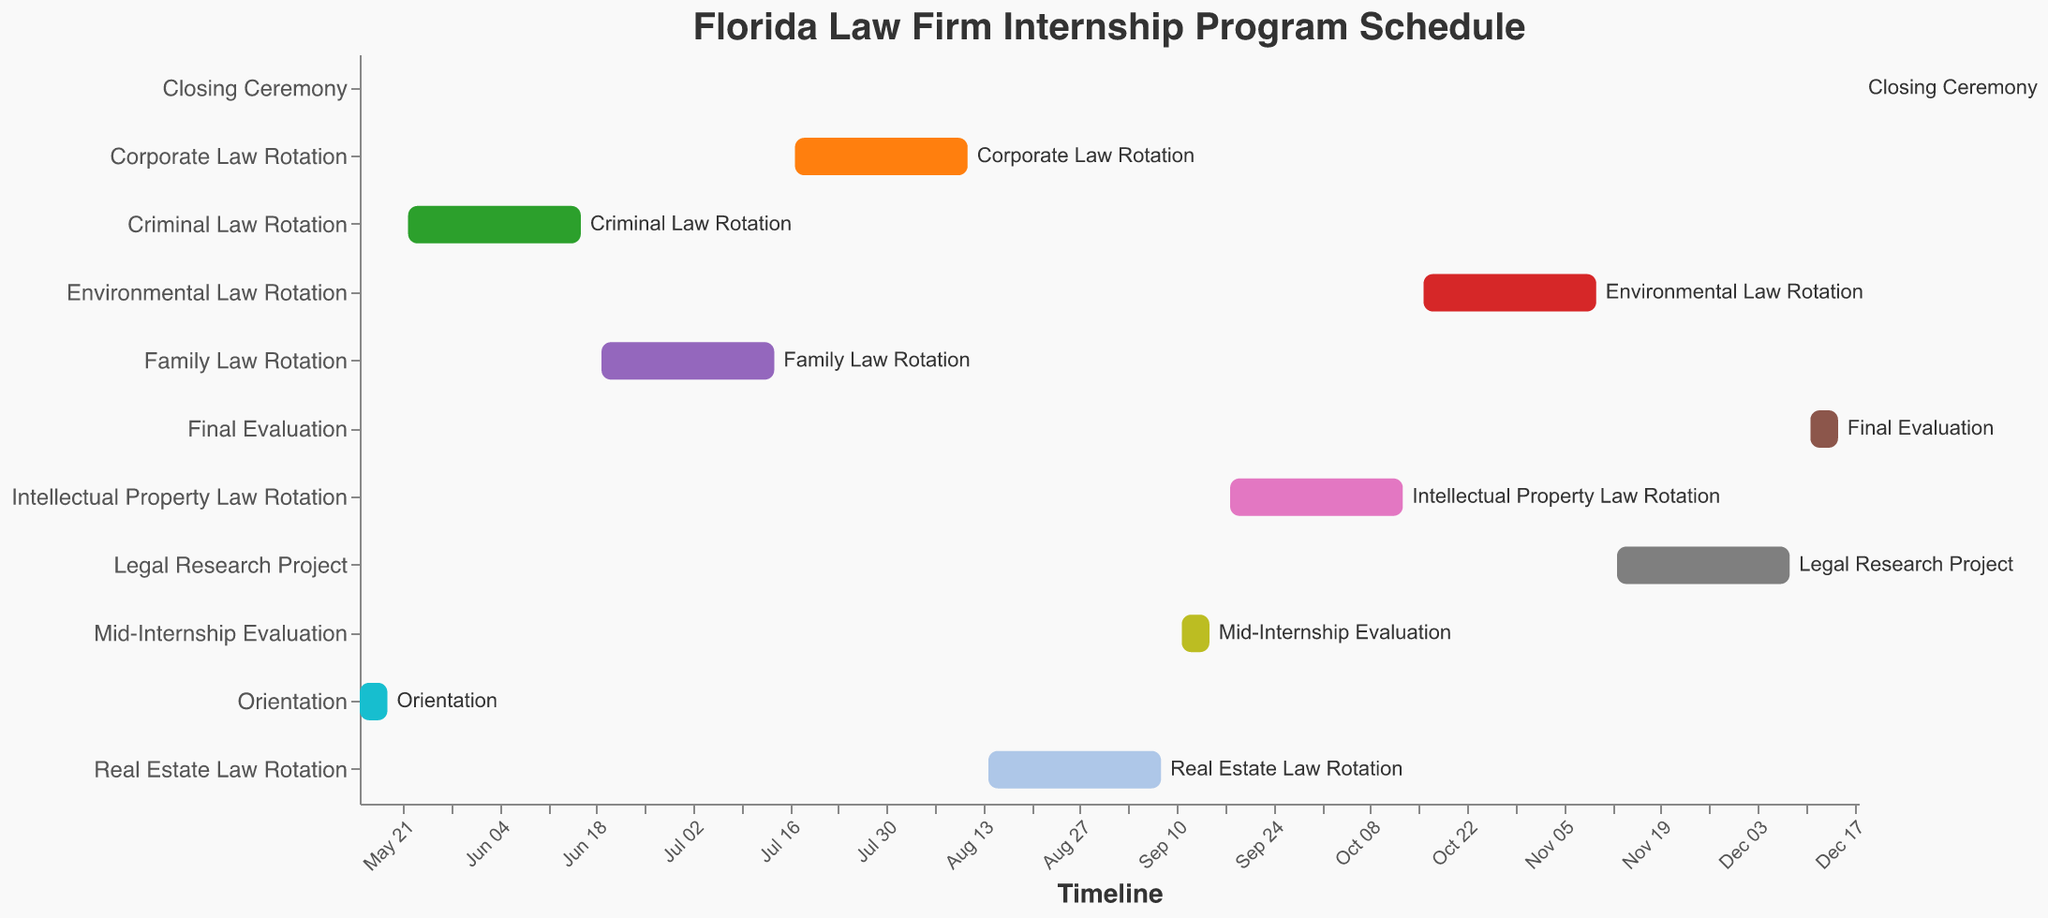How long does the Corporate Law Rotation last? To find the duration, identify the start and end dates for the Corporate Law Rotation. The start date is July 17, 2023, and the end date is August 11, 2023. Count the days from the start date to the end date.
Answer: 26 days When does the longest rotation start and end? Scan all the tasks to identify the longest rotation. The longest rotation is the Criminal Law Rotation, starting on May 22, 2023, and ending on June 16, 2023.
Answer: May 22, 2023 - June 16, 2023 Which rotation directly follows the Mid-Internship Evaluation? Locate the Mid-Internship Evaluation, which is scheduled from September 11 to September 15. The next task on the timeline is the Intellectual Property Law Rotation starting on September 18, 2023.
Answer: Intellectual Property Law Rotation How many total tasks are included in the internship program? Count the number of different tasks listed on the y-axis of the Gantt chart.
Answer: 11 tasks What is the duration of the Legal Research Project, and how does it compare to the Final Evaluation? The Legal Research Project runs from November 13 to December 8, which is 26 days. The Final Evaluation runs from December 11 to December 15, which is 5 days. Comparing the durations, the Legal Research Project is 21 days longer than the Final Evaluation.
Answer: Legal Research Project: 26 days, Final Evaluation: 5 days, Difference: 21 days When is the Closing Ceremony held? Look at the end of the Gantt chart to find the Closing Ceremony, which is on December 18, 2023.
Answer: December 18, 2023 Between which dates does the Family Law Rotation occur? Locate the Family Law Rotation on the y-axis and trace the corresponding range on the x-axis, which shows it runs from June 19, 2023, to July 14, 2023.
Answer: June 19, 2023 - July 14, 2023 How many days are there between the end of the Real Estate Law Rotation and the start of the Mid-Internship Evaluation? The Real Estate Law Rotation ends on September 8, and the Mid-Internship Evaluation starts on September 11. Counting the days between these dates: September 9 and 10 are two days.
Answer: 2 days List all tasks that occur in December. Identify tasks with start or end dates in December. These are the Legal Research Project ending on December 8, the Final Evaluation from December 11-15, and the Closing Ceremony on December 18.
Answer: Legal Research Project, Final Evaluation, Closing Ceremony 